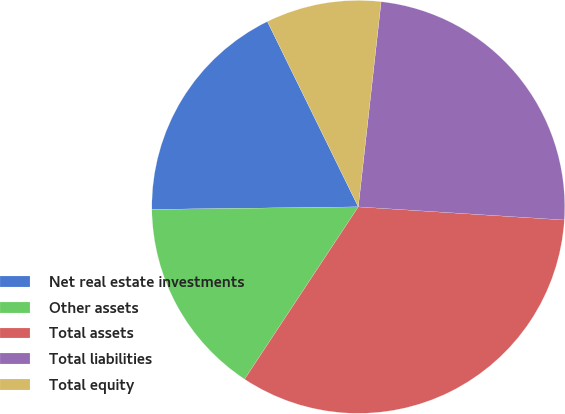Convert chart. <chart><loc_0><loc_0><loc_500><loc_500><pie_chart><fcel>Net real estate investments<fcel>Other assets<fcel>Total assets<fcel>Total liabilities<fcel>Total equity<nl><fcel>17.94%<fcel>15.52%<fcel>33.27%<fcel>24.25%<fcel>9.02%<nl></chart> 